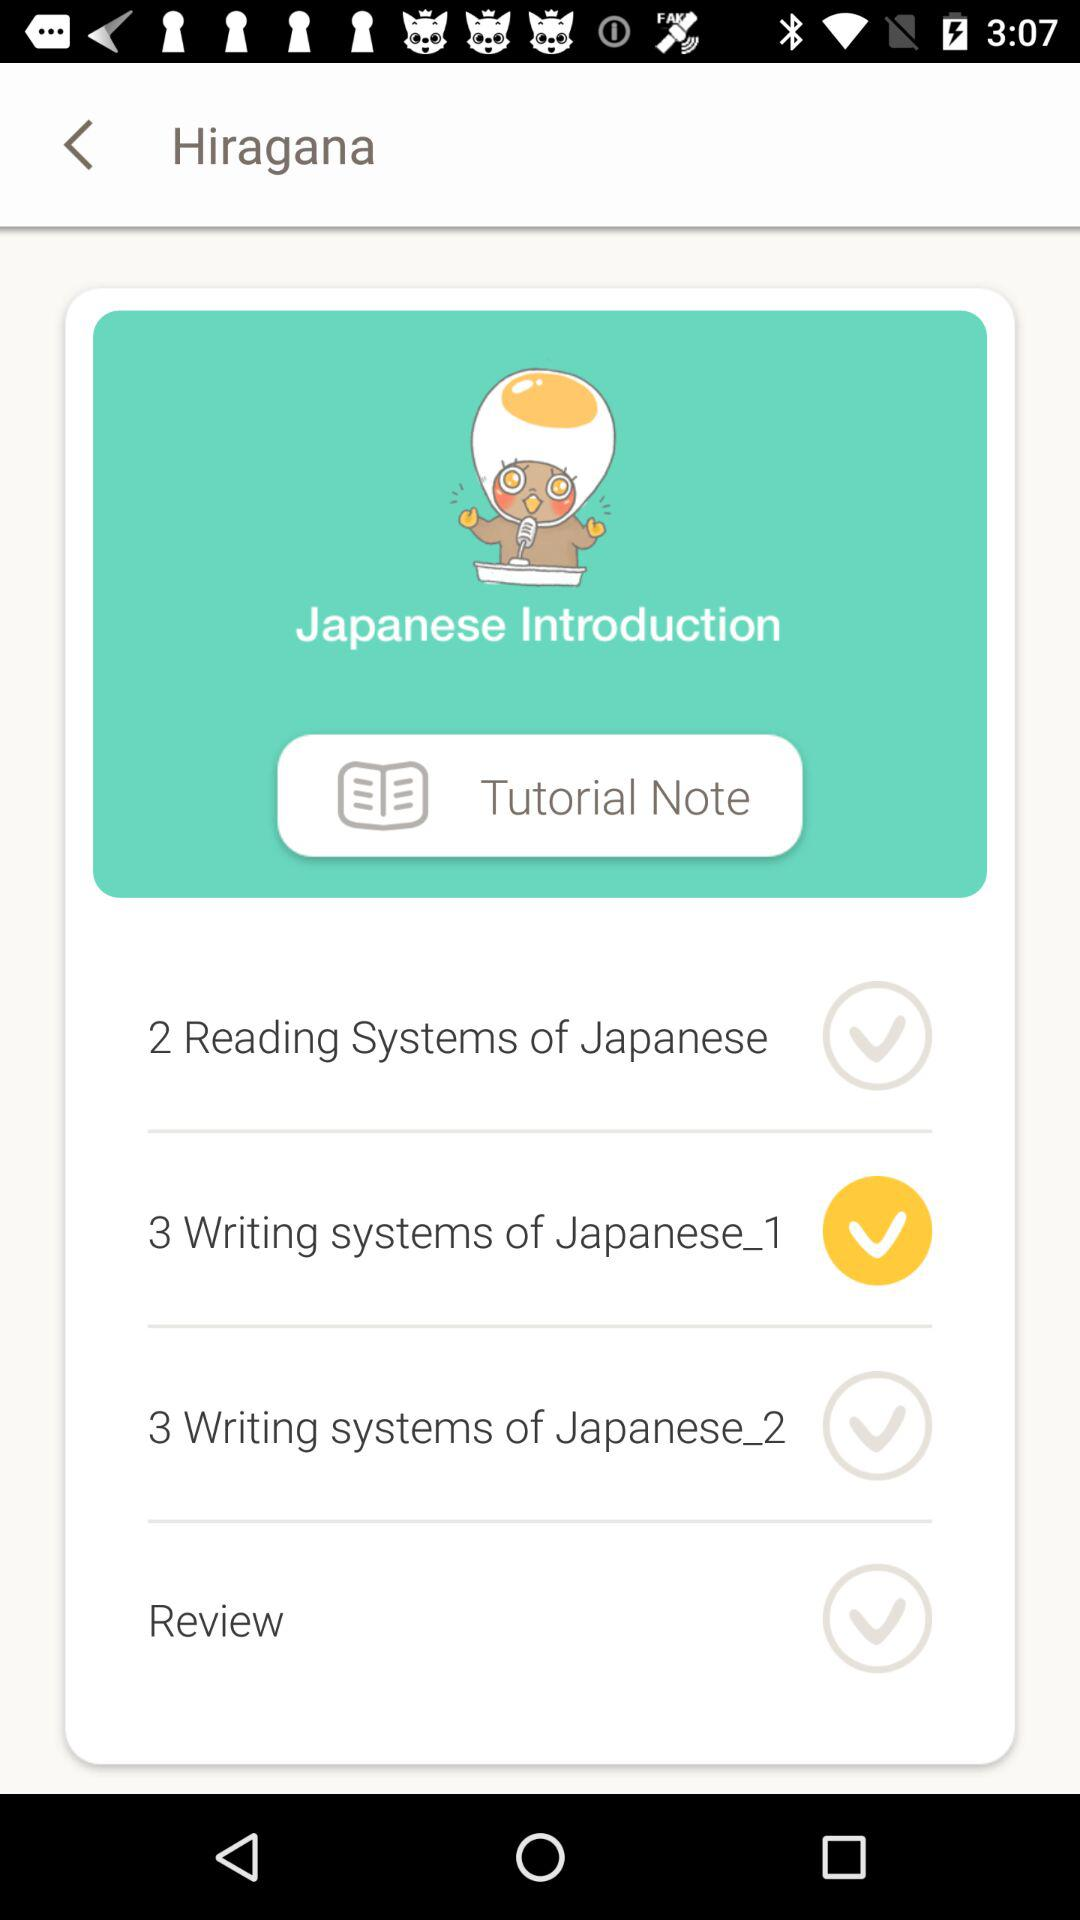Which writing system is selected? The selected writing system is "Japanese_1". 